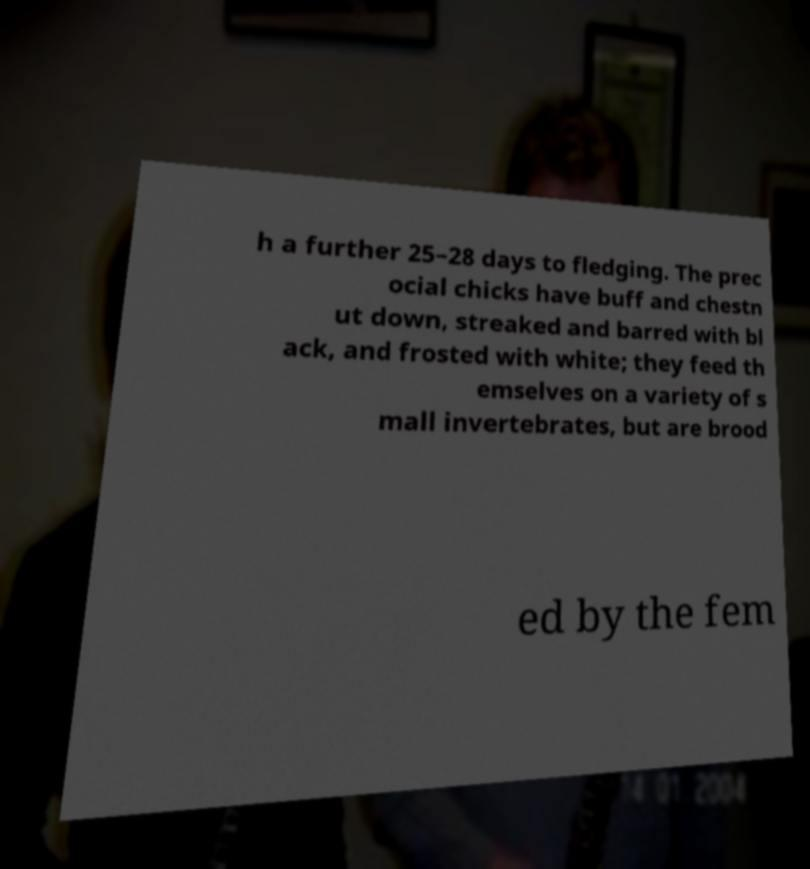Can you read and provide the text displayed in the image?This photo seems to have some interesting text. Can you extract and type it out for me? h a further 25–28 days to fledging. The prec ocial chicks have buff and chestn ut down, streaked and barred with bl ack, and frosted with white; they feed th emselves on a variety of s mall invertebrates, but are brood ed by the fem 